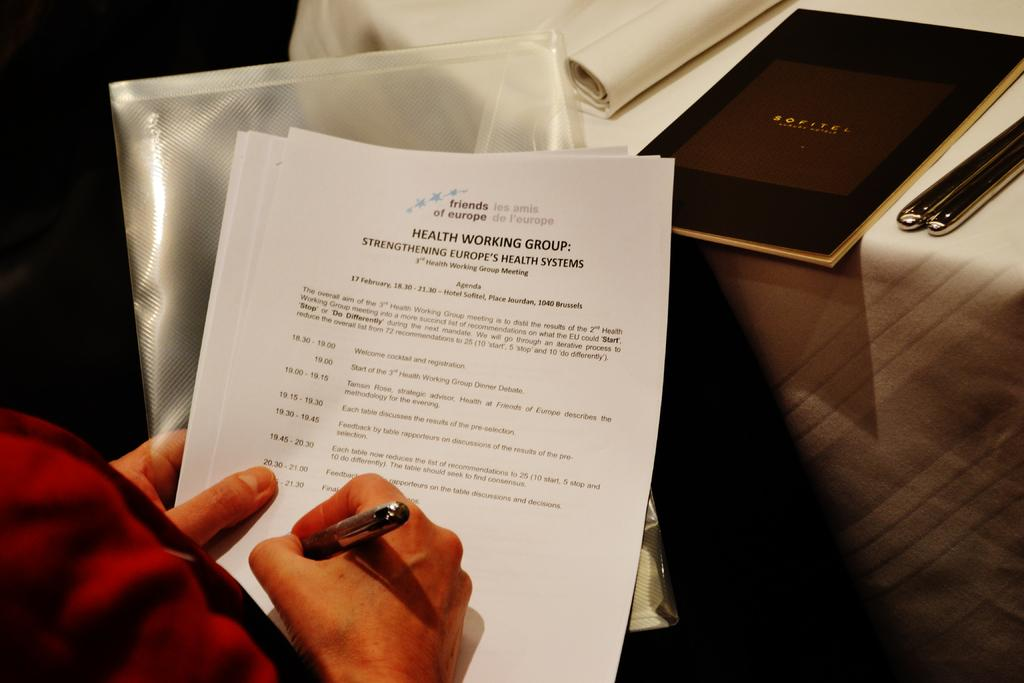<image>
Give a short and clear explanation of the subsequent image. A person sits taking notes at a table with a Sofitel Luxury Hotel menu placed next to cutlery. 